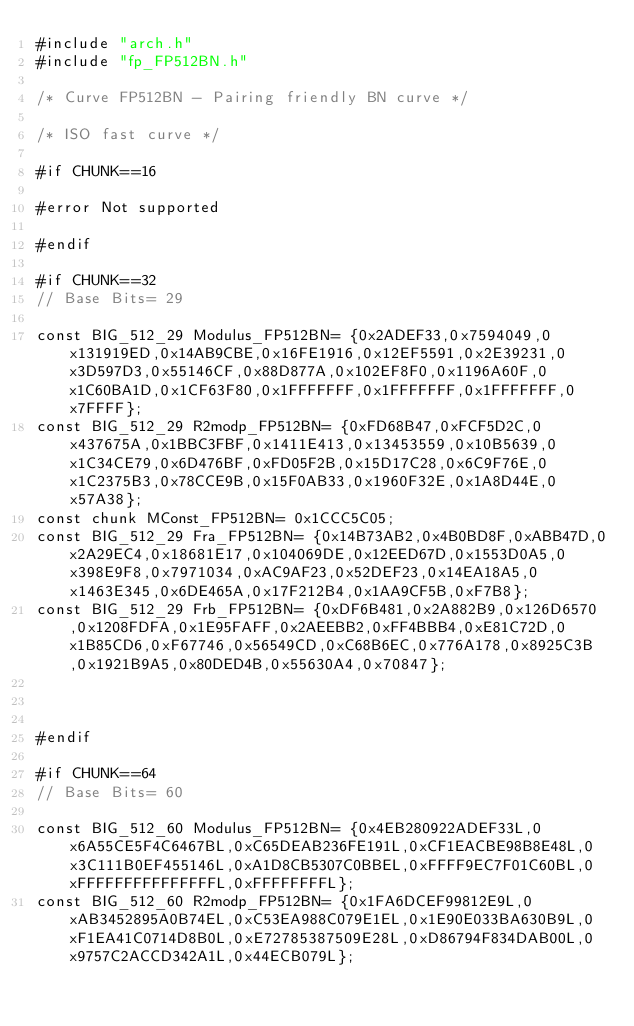<code> <loc_0><loc_0><loc_500><loc_500><_C_>#include "arch.h"
#include "fp_FP512BN.h"

/* Curve FP512BN - Pairing friendly BN curve */

/* ISO fast curve */

#if CHUNK==16

#error Not supported

#endif

#if CHUNK==32
// Base Bits= 29

const BIG_512_29 Modulus_FP512BN= {0x2ADEF33,0x7594049,0x131919ED,0x14AB9CBE,0x16FE1916,0x12EF5591,0x2E39231,0x3D597D3,0x55146CF,0x88D877A,0x102EF8F0,0x1196A60F,0x1C60BA1D,0x1CF63F80,0x1FFFFFFF,0x1FFFFFFF,0x1FFFFFFF,0x7FFFF};
const BIG_512_29 R2modp_FP512BN= {0xFD68B47,0xFCF5D2C,0x437675A,0x1BBC3FBF,0x1411E413,0x13453559,0x10B5639,0x1C34CE79,0x6D476BF,0xFD05F2B,0x15D17C28,0x6C9F76E,0x1C2375B3,0x78CCE9B,0x15F0AB33,0x1960F32E,0x1A8D44E,0x57A38};
const chunk MConst_FP512BN= 0x1CCC5C05;
const BIG_512_29 Fra_FP512BN= {0x14B73AB2,0x4B0BD8F,0xABB47D,0x2A29EC4,0x18681E17,0x104069DE,0x12EED67D,0x1553D0A5,0x398E9F8,0x7971034,0xAC9AF23,0x52DEF23,0x14EA18A5,0x1463E345,0x6DE465A,0x17F212B4,0x1AA9CF5B,0xF7B8};
const BIG_512_29 Frb_FP512BN= {0xDF6B481,0x2A882B9,0x126D6570,0x1208FDFA,0x1E95FAFF,0x2AEEBB2,0xFF4BBB4,0xE81C72D,0x1B85CD6,0xF67746,0x56549CD,0xC68B6EC,0x776A178,0x8925C3B,0x1921B9A5,0x80DED4B,0x55630A4,0x70847};



#endif

#if CHUNK==64
// Base Bits= 60

const BIG_512_60 Modulus_FP512BN= {0x4EB280922ADEF33L,0x6A55CE5F4C6467BL,0xC65DEAB236FE191L,0xCF1EACBE98B8E48L,0x3C111B0EF455146L,0xA1D8CB5307C0BBEL,0xFFFF9EC7F01C60BL,0xFFFFFFFFFFFFFFFL,0xFFFFFFFFL};
const BIG_512_60 R2modp_FP512BN= {0x1FA6DCEF99812E9L,0xAB3452895A0B74EL,0xC53EA988C079E1EL,0x1E90E033BA630B9L,0xF1EA41C0714D8B0L,0xE72785387509E28L,0xD86794F834DAB00L,0x9757C2ACCD342A1L,0x44ECB079L};</code> 